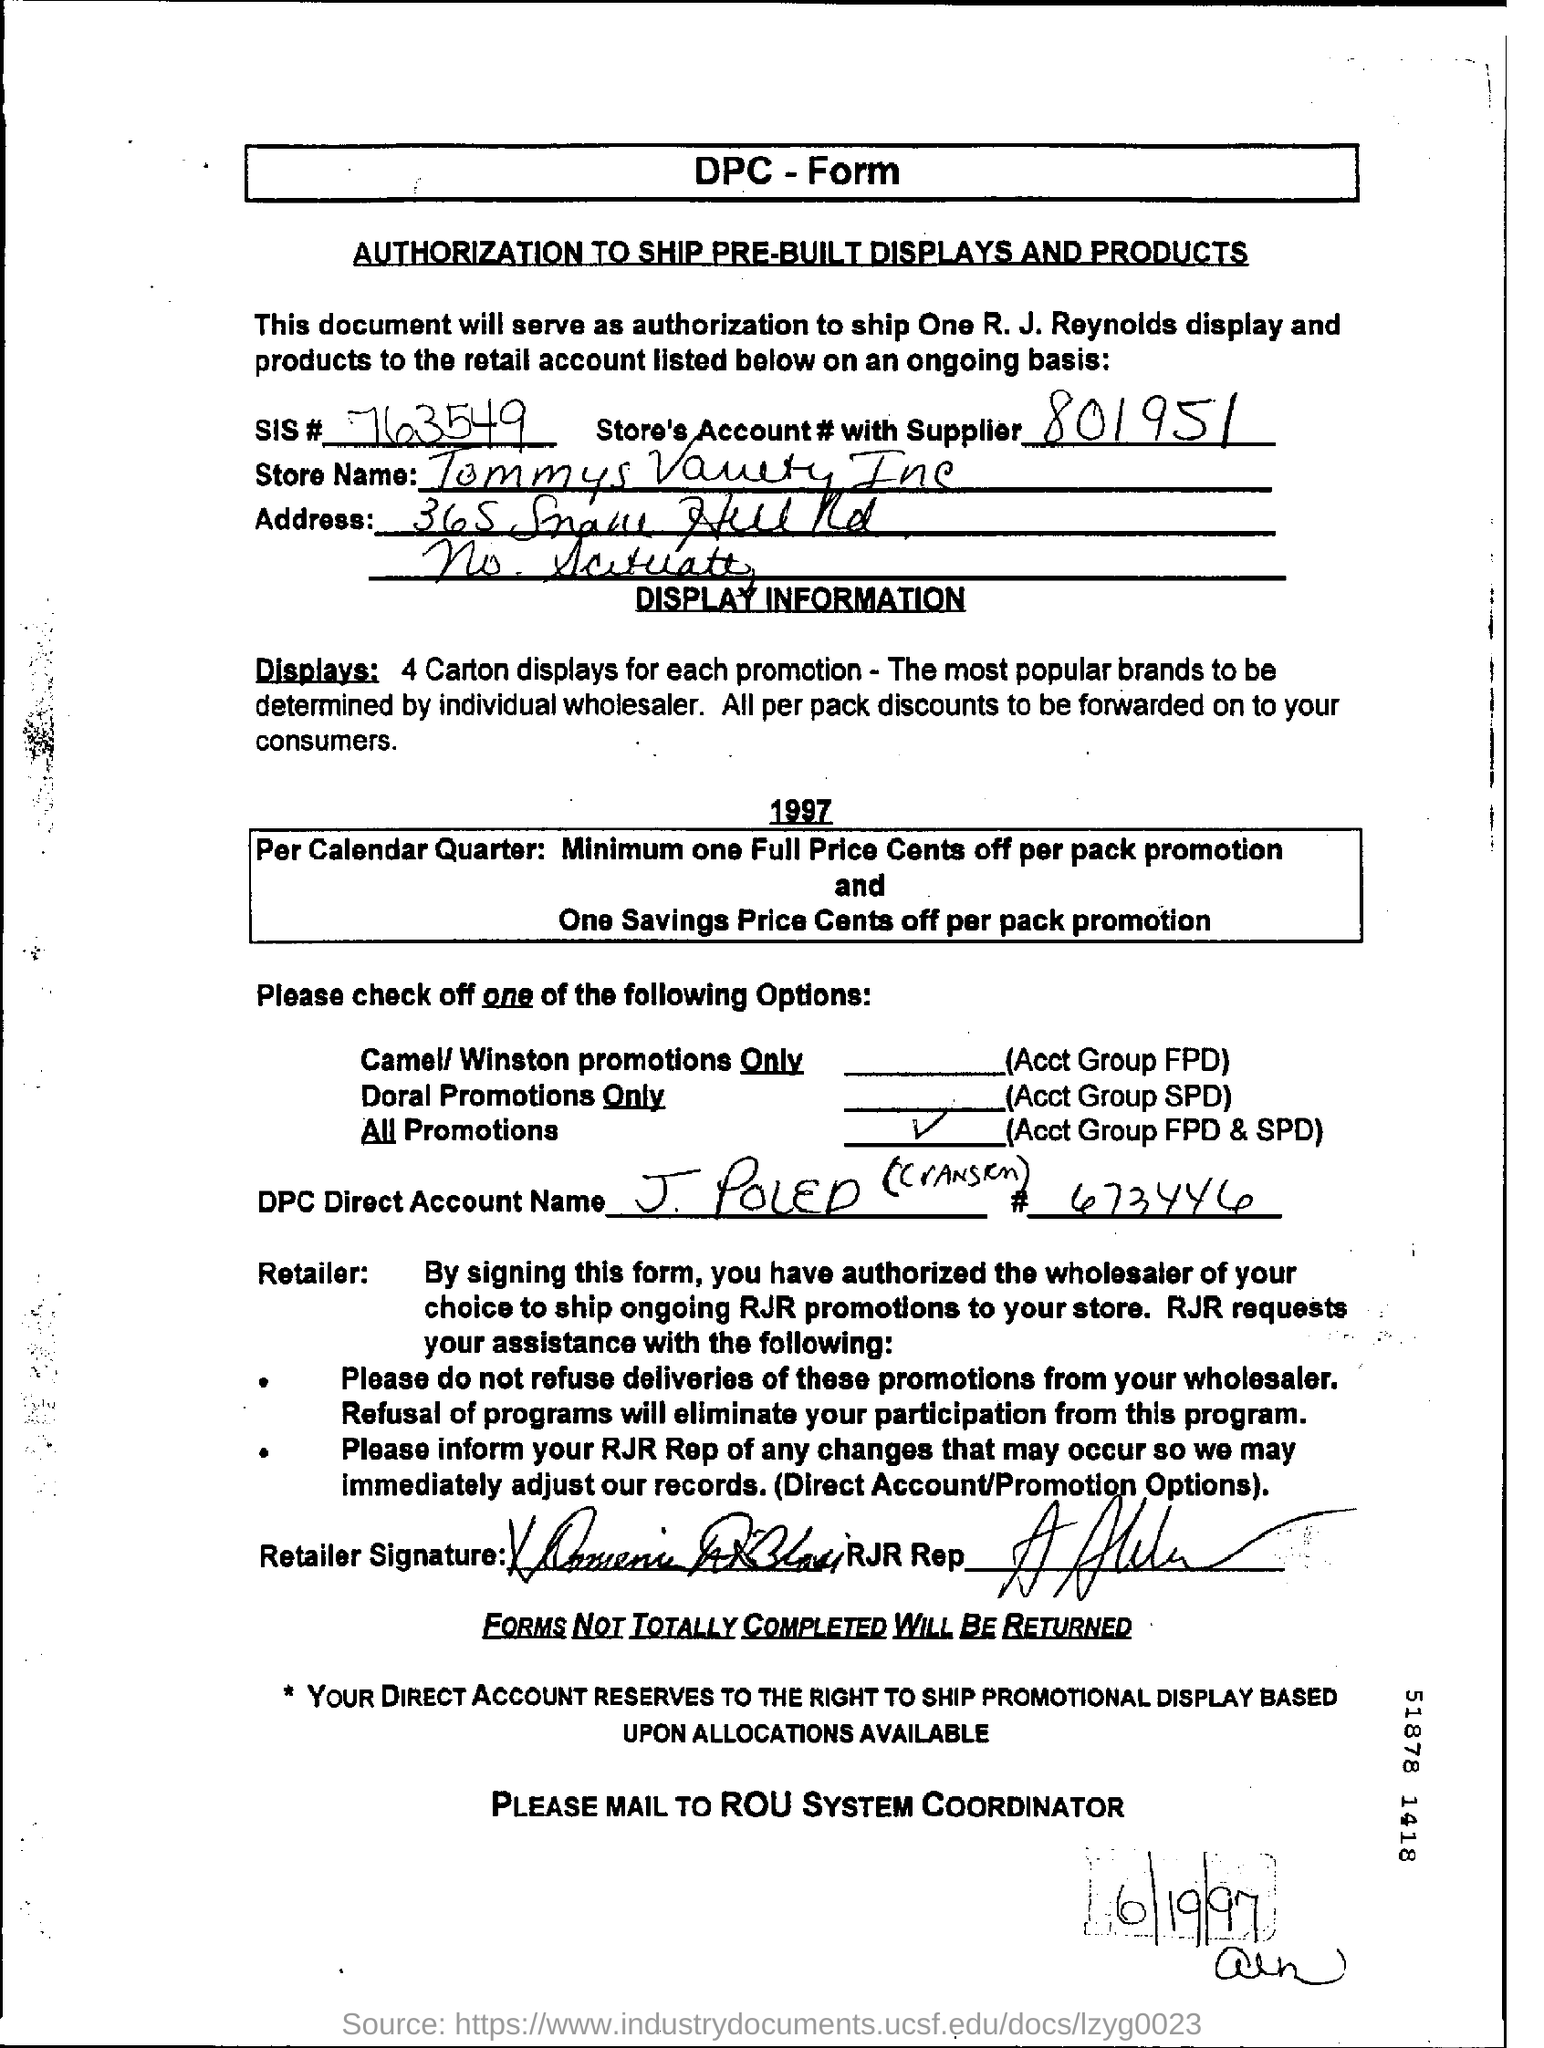List a handful of essential elements in this visual. The name of the form is DPC. The SIS number is 763549... Can you please provide the store's account number with the supplier, which is 801951...? There will be four carton displays for each promotion. 